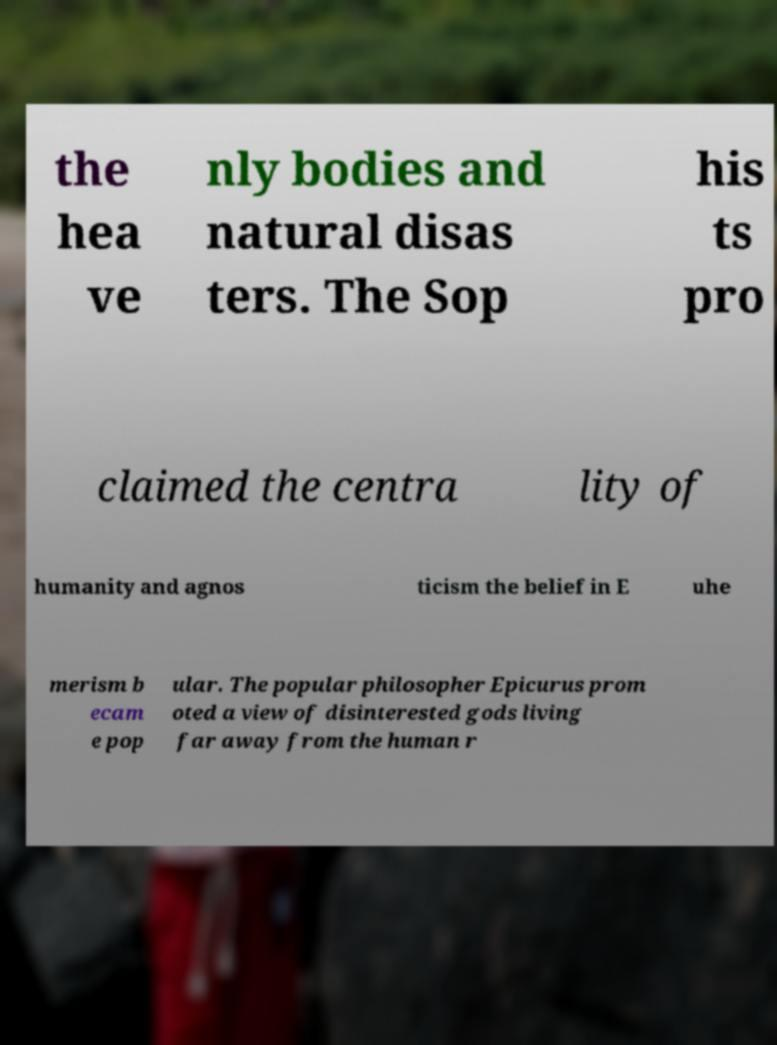I need the written content from this picture converted into text. Can you do that? the hea ve nly bodies and natural disas ters. The Sop his ts pro claimed the centra lity of humanity and agnos ticism the belief in E uhe merism b ecam e pop ular. The popular philosopher Epicurus prom oted a view of disinterested gods living far away from the human r 